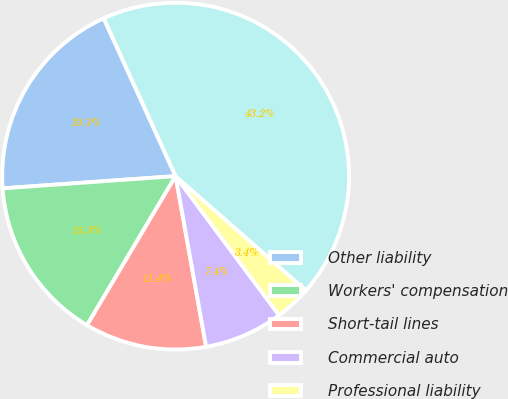Convert chart. <chart><loc_0><loc_0><loc_500><loc_500><pie_chart><fcel>Other liability<fcel>Workers' compensation<fcel>Short-tail lines<fcel>Commercial auto<fcel>Professional liability<fcel>Total<nl><fcel>19.33%<fcel>15.34%<fcel>11.35%<fcel>7.36%<fcel>3.37%<fcel>43.25%<nl></chart> 